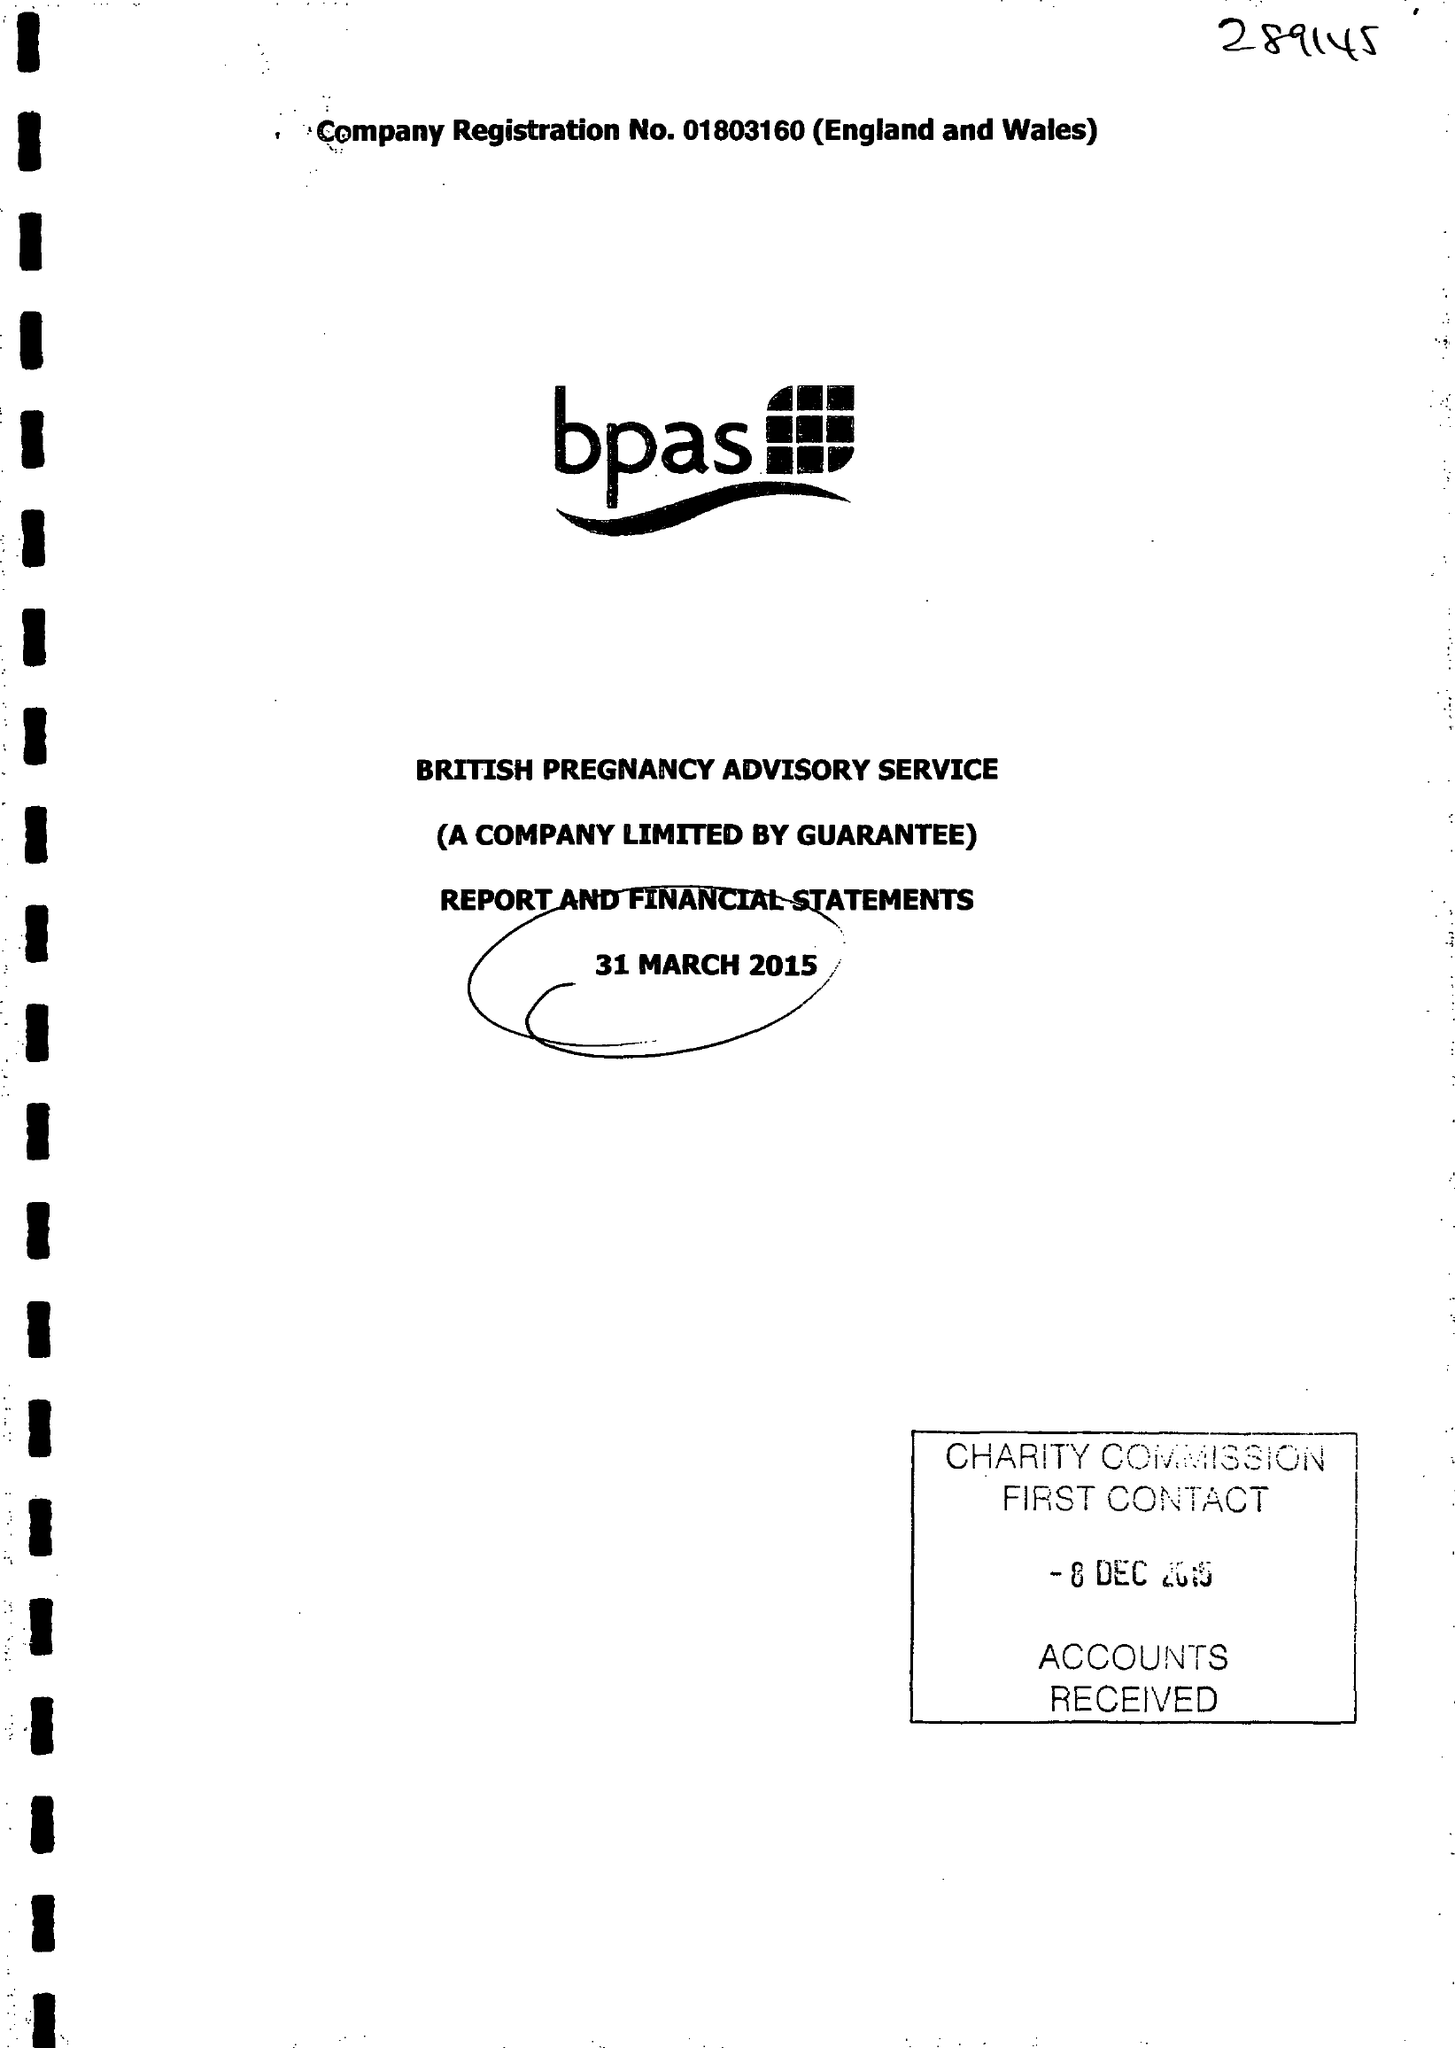What is the value for the address__post_town?
Answer the question using a single word or phrase. STRATFORD-UPON-AVON 